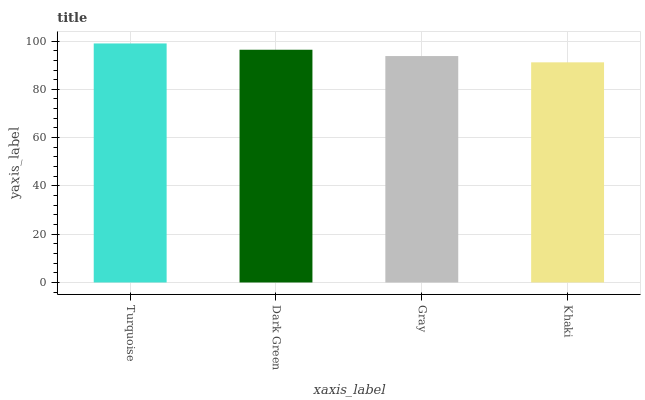Is Khaki the minimum?
Answer yes or no. Yes. Is Turquoise the maximum?
Answer yes or no. Yes. Is Dark Green the minimum?
Answer yes or no. No. Is Dark Green the maximum?
Answer yes or no. No. Is Turquoise greater than Dark Green?
Answer yes or no. Yes. Is Dark Green less than Turquoise?
Answer yes or no. Yes. Is Dark Green greater than Turquoise?
Answer yes or no. No. Is Turquoise less than Dark Green?
Answer yes or no. No. Is Dark Green the high median?
Answer yes or no. Yes. Is Gray the low median?
Answer yes or no. Yes. Is Khaki the high median?
Answer yes or no. No. Is Dark Green the low median?
Answer yes or no. No. 